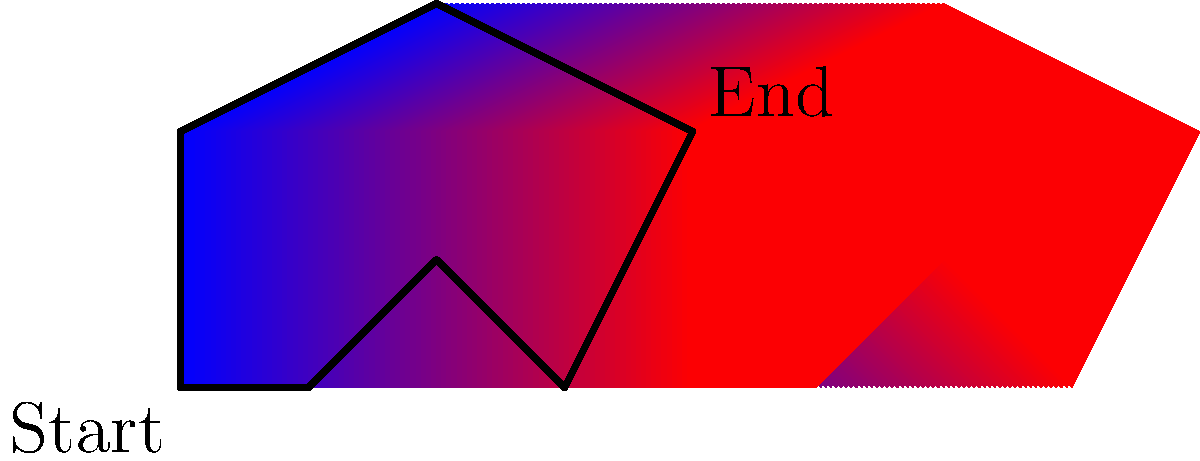As a graphic designer incorporating Python into your workflow, you're tasked with creating a color gradient across a complex polygon shape. The gradient should transition from blue at the leftmost point to red at the rightmost point. Given the polygon shown in the image, what Python library and technique would you use to efficiently implement this gradient fill? To implement a color gradient across a complex polygon shape in Python, you can follow these steps:

1. Choose an appropriate library: For this task, the Pillow (PIL) library is ideal as it provides powerful image processing capabilities.

2. Create the polygon shape:
   - Use the `PIL.Image` module to create a new image.
   - Use the `PIL.ImageDraw` module to draw the polygon on the image.

3. Implement the gradient:
   - Calculate the bounding box of the polygon.
   - Create a linear gradient from left to right:
     a. For each pixel column, calculate its relative position (0 to 1) within the bounding box.
     b. Use this position to interpolate between blue (0, 0, 255) and red (255, 0, 0).

4. Apply the gradient to the polygon:
   - Create a mask of the polygon shape.
   - Use the `PIL.Image.paste()` method with the mask to apply the gradient only within the polygon.

Here's a Python code snippet to achieve this:

```python
from PIL import Image, ImageDraw
import numpy as np

def create_gradient_polygon(points, size):
    # Create image and draw polygon
    img = Image.new('RGB', size, color='white')
    mask = Image.new('L', size, color=0)
    draw = ImageDraw.Draw(mask)
    draw.polygon(points, fill=255)

    # Create gradient
    gradient = np.linspace(0, 1, size[0])
    gradient = np.tile(gradient, (size[1], 1))
    
    # Convert gradient to RGB
    gradient_rgb = np.zeros((size[1], size[0], 3), dtype=np.uint8)
    gradient_rgb[:,:,0] = gradient * 255  # Red channel
    gradient_rgb[:,:,2] = (1 - gradient) * 255  # Blue channel

    # Apply gradient to polygon
    gradient_img = Image.fromarray(gradient_rgb)
    img.paste(gradient_img, (0, 0), mask)

    return img

# Usage
points = [(0,100), (50,0), (100,50), (150,0), (200,100), (100,150)]
img = create_gradient_polygon(points, (200, 150))
img.save('gradient_polygon.png')
```

This approach uses NumPy for efficient array operations and Pillow for image manipulation, providing a fast and flexible solution for creating gradients on complex shapes.
Answer: Pillow (PIL) library with NumPy, using masking and array operations 